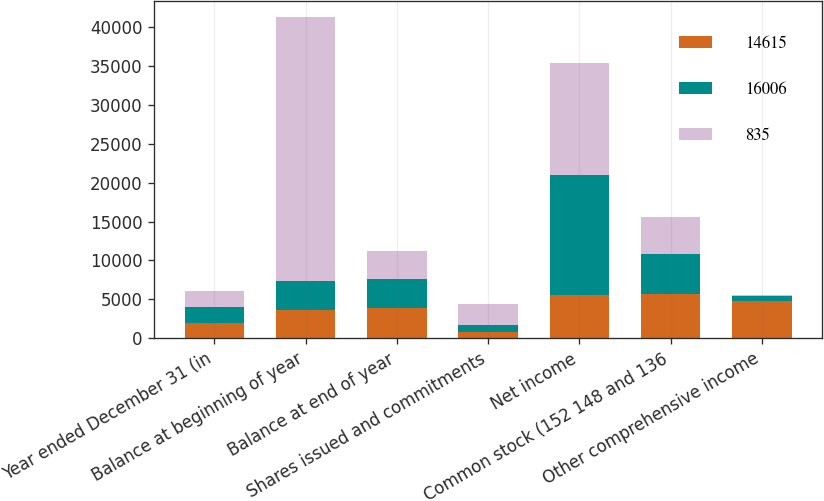Convert chart. <chart><loc_0><loc_0><loc_500><loc_500><stacked_bar_chart><ecel><fcel>Year ended December 31 (in<fcel>Balance at beginning of year<fcel>Balance at end of year<fcel>Shares issued and commitments<fcel>Net income<fcel>Common stock (152 148 and 136<fcel>Other comprehensive income<nl><fcel>14615<fcel>2008<fcel>3658<fcel>3942<fcel>859<fcel>5605<fcel>5633<fcel>4770<nl><fcel>16006<fcel>2007<fcel>3658<fcel>3658<fcel>790<fcel>15365<fcel>5165<fcel>641<nl><fcel>835<fcel>2006<fcel>34020<fcel>3658<fcel>2813<fcel>14444<fcel>4860<fcel>171<nl></chart> 